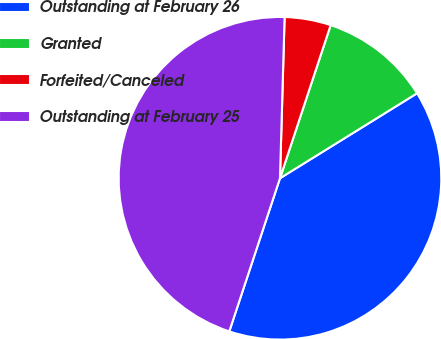Convert chart. <chart><loc_0><loc_0><loc_500><loc_500><pie_chart><fcel>Outstanding at February 26<fcel>Granted<fcel>Forfeited/Canceled<fcel>Outstanding at February 25<nl><fcel>38.92%<fcel>11.08%<fcel>4.63%<fcel>45.37%<nl></chart> 